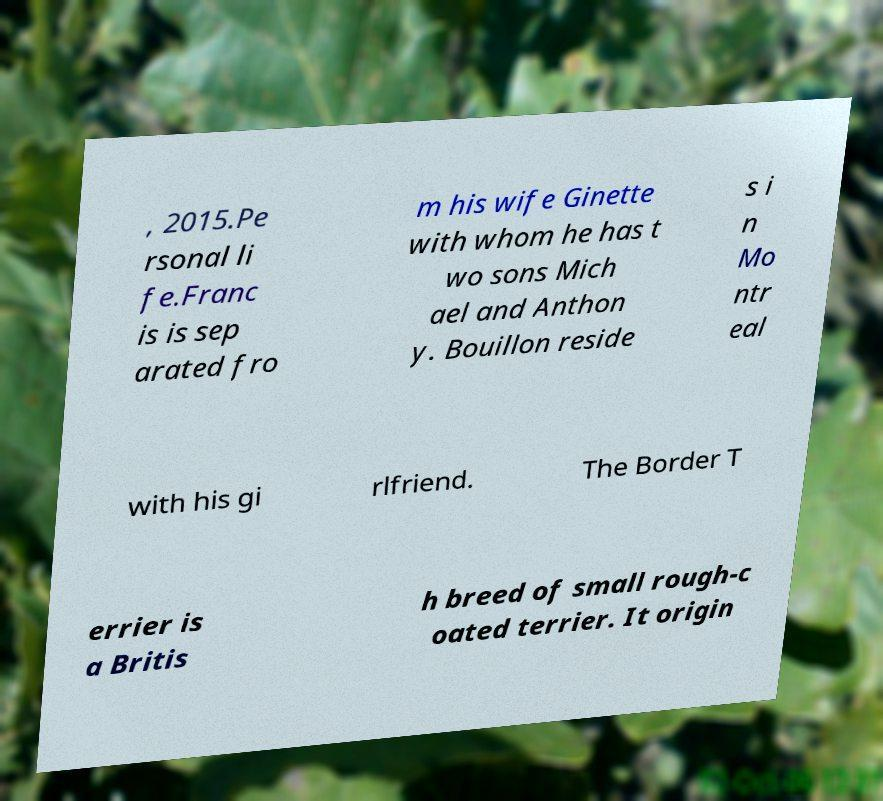I need the written content from this picture converted into text. Can you do that? , 2015.Pe rsonal li fe.Franc is is sep arated fro m his wife Ginette with whom he has t wo sons Mich ael and Anthon y. Bouillon reside s i n Mo ntr eal with his gi rlfriend. The Border T errier is a Britis h breed of small rough-c oated terrier. It origin 